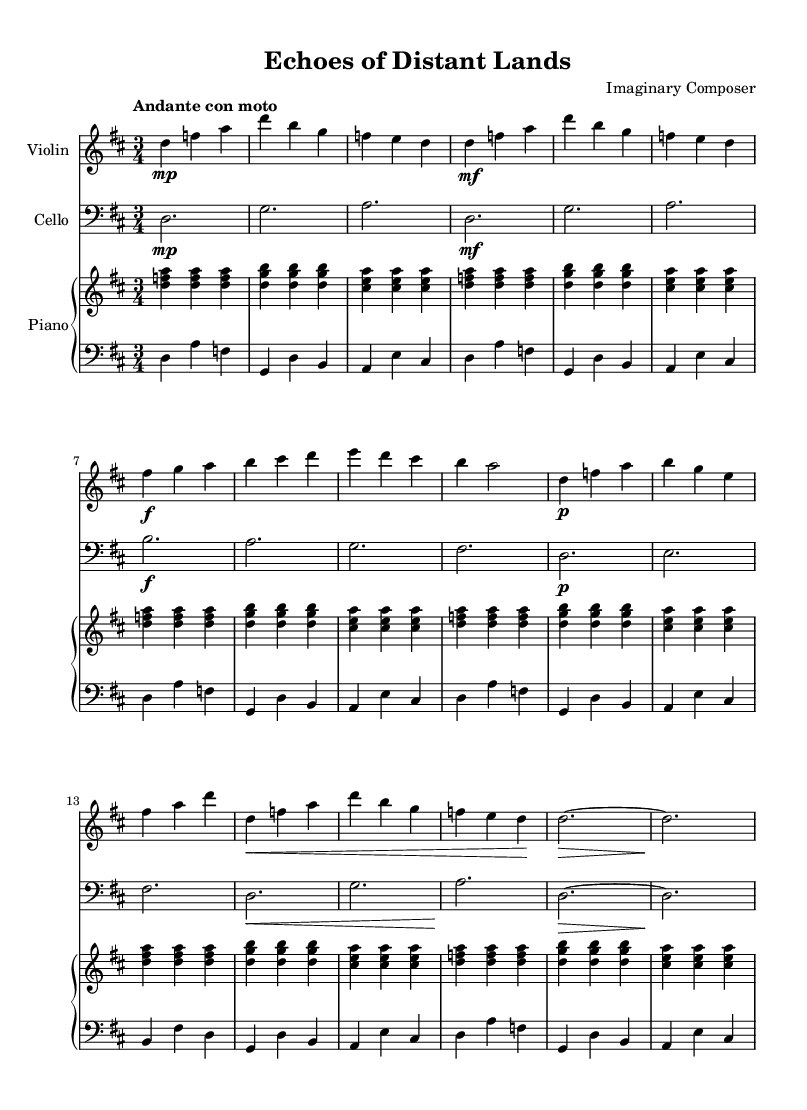What is the key signature of this music? The key signature with two sharps indicates that the piece is in the key of D major. The presence of F# and C# confirms this.
Answer: D major What is the time signature of the piece? The time signature shown at the beginning of the music is 3/4, which means there are three beats per measure and a quarter note receives one beat.
Answer: 3/4 What is the tempo marking for this composition? The tempo marking written at the beginning shows "Andante con moto," which describes a moderate speed with some motion.
Answer: Andante con moto How many themes are presented in the piece? By analyzing the structure, there are two distinct themes labeled as Theme A and Theme B in the score.
Answer: Two themes In which section does the recapitulation occur? The recapitulation appears after the development section, indicated by the text "Recapitulation" in the score, which revisits Theme A and B.
Answer: Recapitulation What dynamic marking is used at the beginning of Theme A? The first dynamic marking for Theme A is "mf," which stands for mezzo-forte, indicating a moderately loud passage.
Answer: mf 